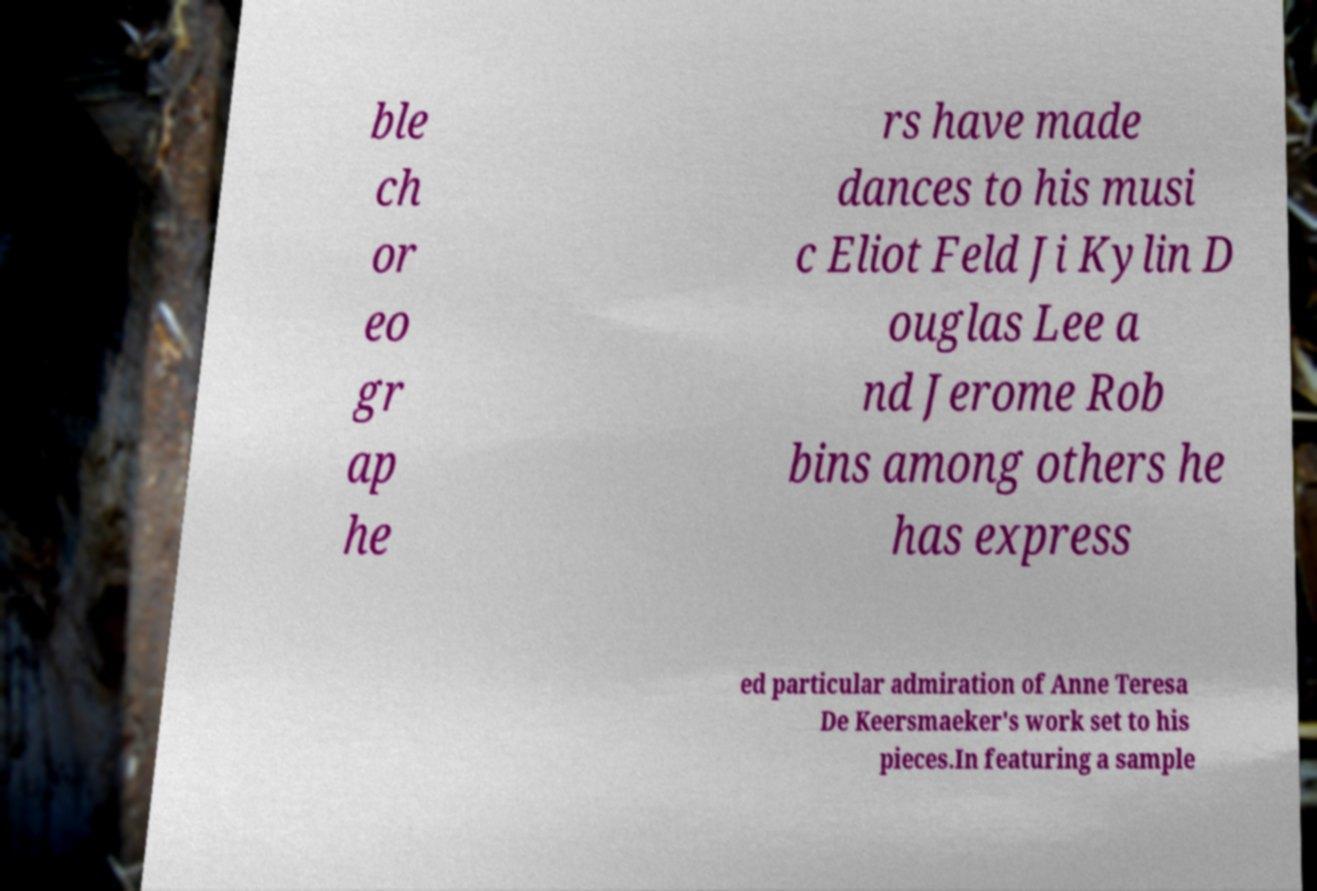I need the written content from this picture converted into text. Can you do that? ble ch or eo gr ap he rs have made dances to his musi c Eliot Feld Ji Kylin D ouglas Lee a nd Jerome Rob bins among others he has express ed particular admiration of Anne Teresa De Keersmaeker's work set to his pieces.In featuring a sample 